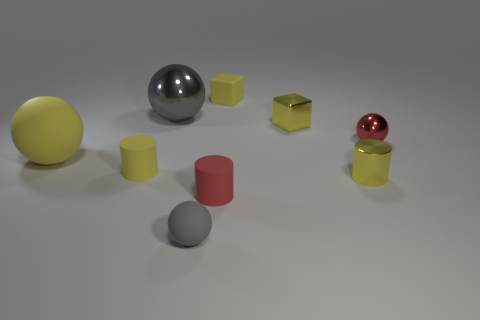Subtract all yellow metallic cylinders. How many cylinders are left? 2 Subtract all yellow spheres. How many spheres are left? 3 Subtract 1 cylinders. How many cylinders are left? 2 Add 1 small brown matte spheres. How many objects exist? 10 Subtract all brown balls. Subtract all purple cubes. How many balls are left? 4 Subtract all blocks. How many objects are left? 7 Subtract all small cyan rubber cubes. Subtract all small shiny cylinders. How many objects are left? 8 Add 4 tiny gray things. How many tiny gray things are left? 5 Add 5 large green rubber cylinders. How many large green rubber cylinders exist? 5 Subtract 2 yellow cylinders. How many objects are left? 7 